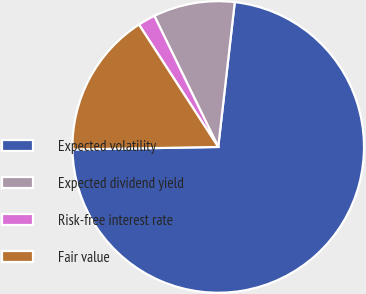Convert chart. <chart><loc_0><loc_0><loc_500><loc_500><pie_chart><fcel>Expected volatility<fcel>Expected dividend yield<fcel>Risk-free interest rate<fcel>Fair value<nl><fcel>72.91%<fcel>9.03%<fcel>1.93%<fcel>16.13%<nl></chart> 